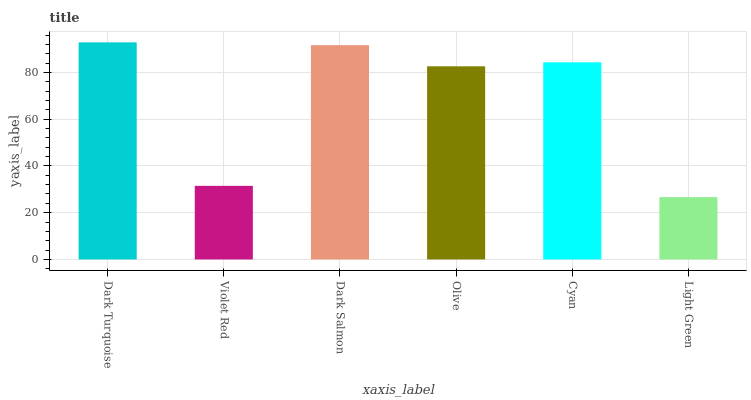Is Light Green the minimum?
Answer yes or no. Yes. Is Dark Turquoise the maximum?
Answer yes or no. Yes. Is Violet Red the minimum?
Answer yes or no. No. Is Violet Red the maximum?
Answer yes or no. No. Is Dark Turquoise greater than Violet Red?
Answer yes or no. Yes. Is Violet Red less than Dark Turquoise?
Answer yes or no. Yes. Is Violet Red greater than Dark Turquoise?
Answer yes or no. No. Is Dark Turquoise less than Violet Red?
Answer yes or no. No. Is Cyan the high median?
Answer yes or no. Yes. Is Olive the low median?
Answer yes or no. Yes. Is Olive the high median?
Answer yes or no. No. Is Light Green the low median?
Answer yes or no. No. 